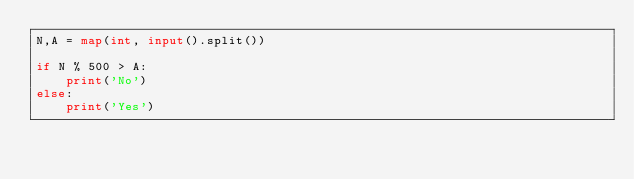Convert code to text. <code><loc_0><loc_0><loc_500><loc_500><_Python_>N,A = map(int, input().split())

if N % 500 > A:
    print('No')
else:
    print('Yes')</code> 